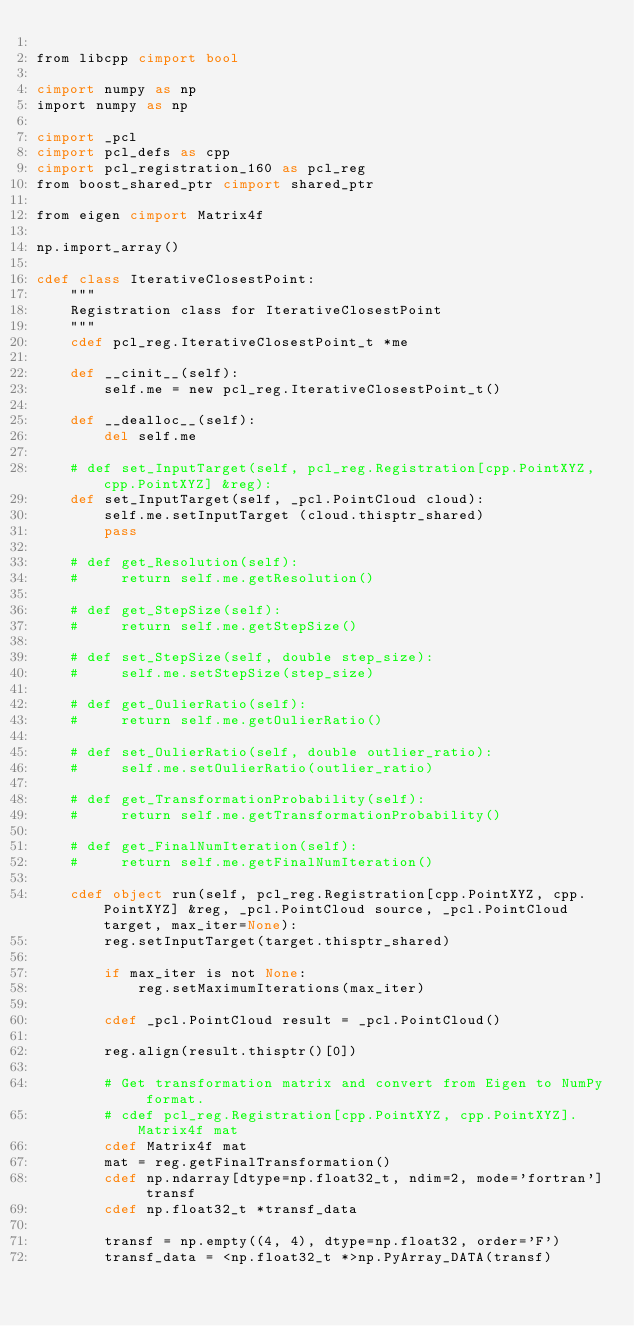Convert code to text. <code><loc_0><loc_0><loc_500><loc_500><_Cython_>
from libcpp cimport bool

cimport numpy as np
import numpy as np

cimport _pcl
cimport pcl_defs as cpp
cimport pcl_registration_160 as pcl_reg
from boost_shared_ptr cimport shared_ptr

from eigen cimport Matrix4f

np.import_array()

cdef class IterativeClosestPoint:
    """
    Registration class for IterativeClosestPoint
    """
    cdef pcl_reg.IterativeClosestPoint_t *me

    def __cinit__(self):
        self.me = new pcl_reg.IterativeClosestPoint_t()

    def __dealloc__(self):
        del self.me

    # def set_InputTarget(self, pcl_reg.Registration[cpp.PointXYZ, cpp.PointXYZ] &reg):
    def set_InputTarget(self, _pcl.PointCloud cloud):
        self.me.setInputTarget (cloud.thisptr_shared)
        pass

    # def get_Resolution(self):
    #     return self.me.getResolution()

    # def get_StepSize(self):
    #     return self.me.getStepSize()

    # def set_StepSize(self, double step_size):
    #     self.me.setStepSize(step_size)

    # def get_OulierRatio(self):
    #     return self.me.getOulierRatio()

    # def set_OulierRatio(self, double outlier_ratio):
    #     self.me.setOulierRatio(outlier_ratio)

    # def get_TransformationProbability(self):
    #     return self.me.getTransformationProbability()

    # def get_FinalNumIteration(self):
    #     return self.me.getFinalNumIteration()

    cdef object run(self, pcl_reg.Registration[cpp.PointXYZ, cpp.PointXYZ] &reg, _pcl.PointCloud source, _pcl.PointCloud target, max_iter=None):
        reg.setInputTarget(target.thisptr_shared)
        
        if max_iter is not None:
            reg.setMaximumIterations(max_iter)
        
        cdef _pcl.PointCloud result = _pcl.PointCloud()
        
        reg.align(result.thisptr()[0])
        
        # Get transformation matrix and convert from Eigen to NumPy format.
        # cdef pcl_reg.Registration[cpp.PointXYZ, cpp.PointXYZ].Matrix4f mat
        cdef Matrix4f mat
        mat = reg.getFinalTransformation()
        cdef np.ndarray[dtype=np.float32_t, ndim=2, mode='fortran'] transf
        cdef np.float32_t *transf_data
        
        transf = np.empty((4, 4), dtype=np.float32, order='F')
        transf_data = <np.float32_t *>np.PyArray_DATA(transf)
        </code> 